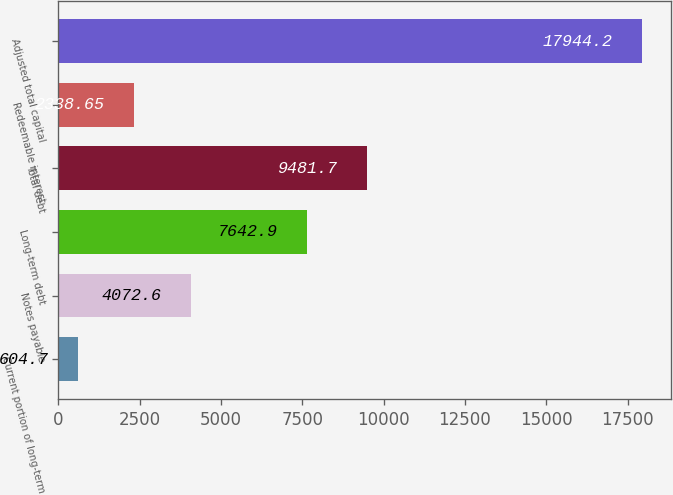Convert chart to OTSL. <chart><loc_0><loc_0><loc_500><loc_500><bar_chart><fcel>Current portion of long-term<fcel>Notes payable<fcel>Long-term debt<fcel>Total debt<fcel>Redeemable interest<fcel>Adjusted total capital<nl><fcel>604.7<fcel>4072.6<fcel>7642.9<fcel>9481.7<fcel>2338.65<fcel>17944.2<nl></chart> 